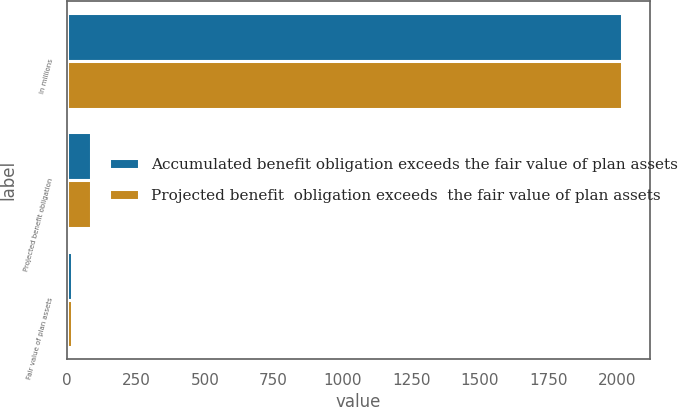Convert chart. <chart><loc_0><loc_0><loc_500><loc_500><stacked_bar_chart><ecel><fcel>In millions<fcel>Projected benefit obligation<fcel>Fair value of plan assets<nl><fcel>Accumulated benefit obligation exceeds the fair value of plan assets<fcel>2016<fcel>87.2<fcel>17.5<nl><fcel>Projected benefit  obligation exceeds  the fair value of plan assets<fcel>2016<fcel>87.2<fcel>17.5<nl></chart> 